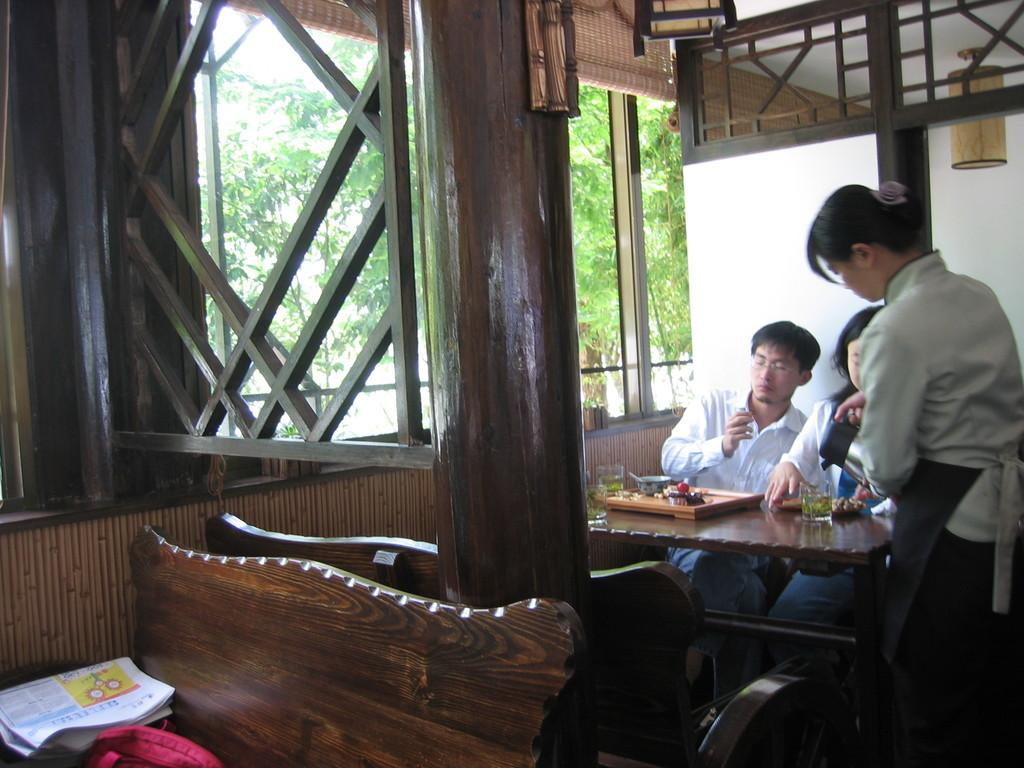How many people are sitting in the chair in the image? There are two persons sitting in a chair in the image. What is in front of the two persons? There is a table in front of the two persons. What is the waiter doing in the image? The waiter is serving water beside the two persons. What can be seen beside the two persons? There is a window beside the two persons. What type of sweater is the person on the left wearing in the image? There is no sweater mentioned or visible in the image. What book is the person on the right reading in the image? There is no book or reading activity depicted in the image. 